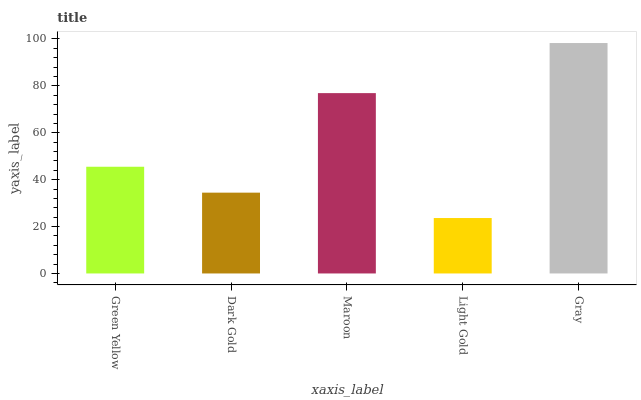Is Dark Gold the minimum?
Answer yes or no. No. Is Dark Gold the maximum?
Answer yes or no. No. Is Green Yellow greater than Dark Gold?
Answer yes or no. Yes. Is Dark Gold less than Green Yellow?
Answer yes or no. Yes. Is Dark Gold greater than Green Yellow?
Answer yes or no. No. Is Green Yellow less than Dark Gold?
Answer yes or no. No. Is Green Yellow the high median?
Answer yes or no. Yes. Is Green Yellow the low median?
Answer yes or no. Yes. Is Gray the high median?
Answer yes or no. No. Is Dark Gold the low median?
Answer yes or no. No. 